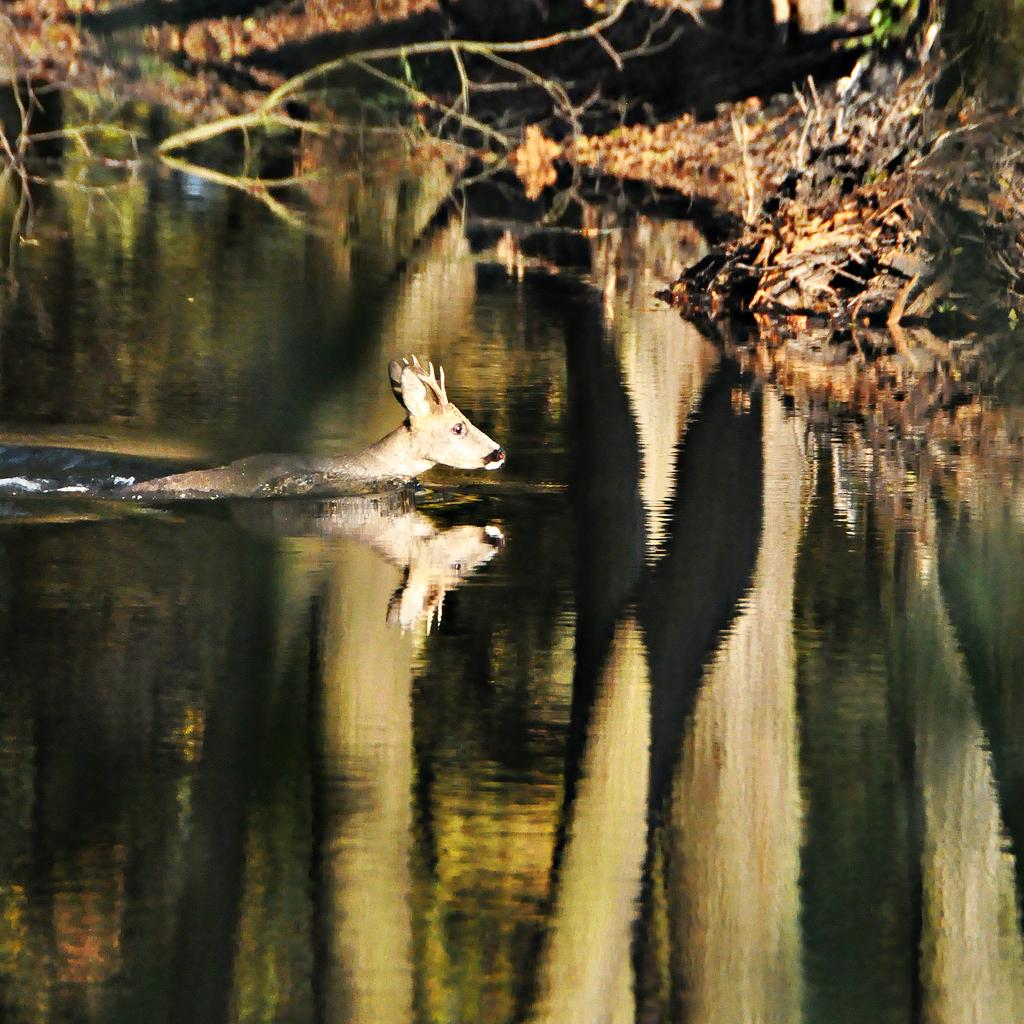What animal is in the water in the image? There is a reindeer in the water in the image. What can be seen on the right side of the image? There is a tree on the right side of the image. How would you describe the background of the image? The backdrop is blurred. What type of order is the reindeer following in the image? There is no indication in the image that the reindeer is following any specific order. 